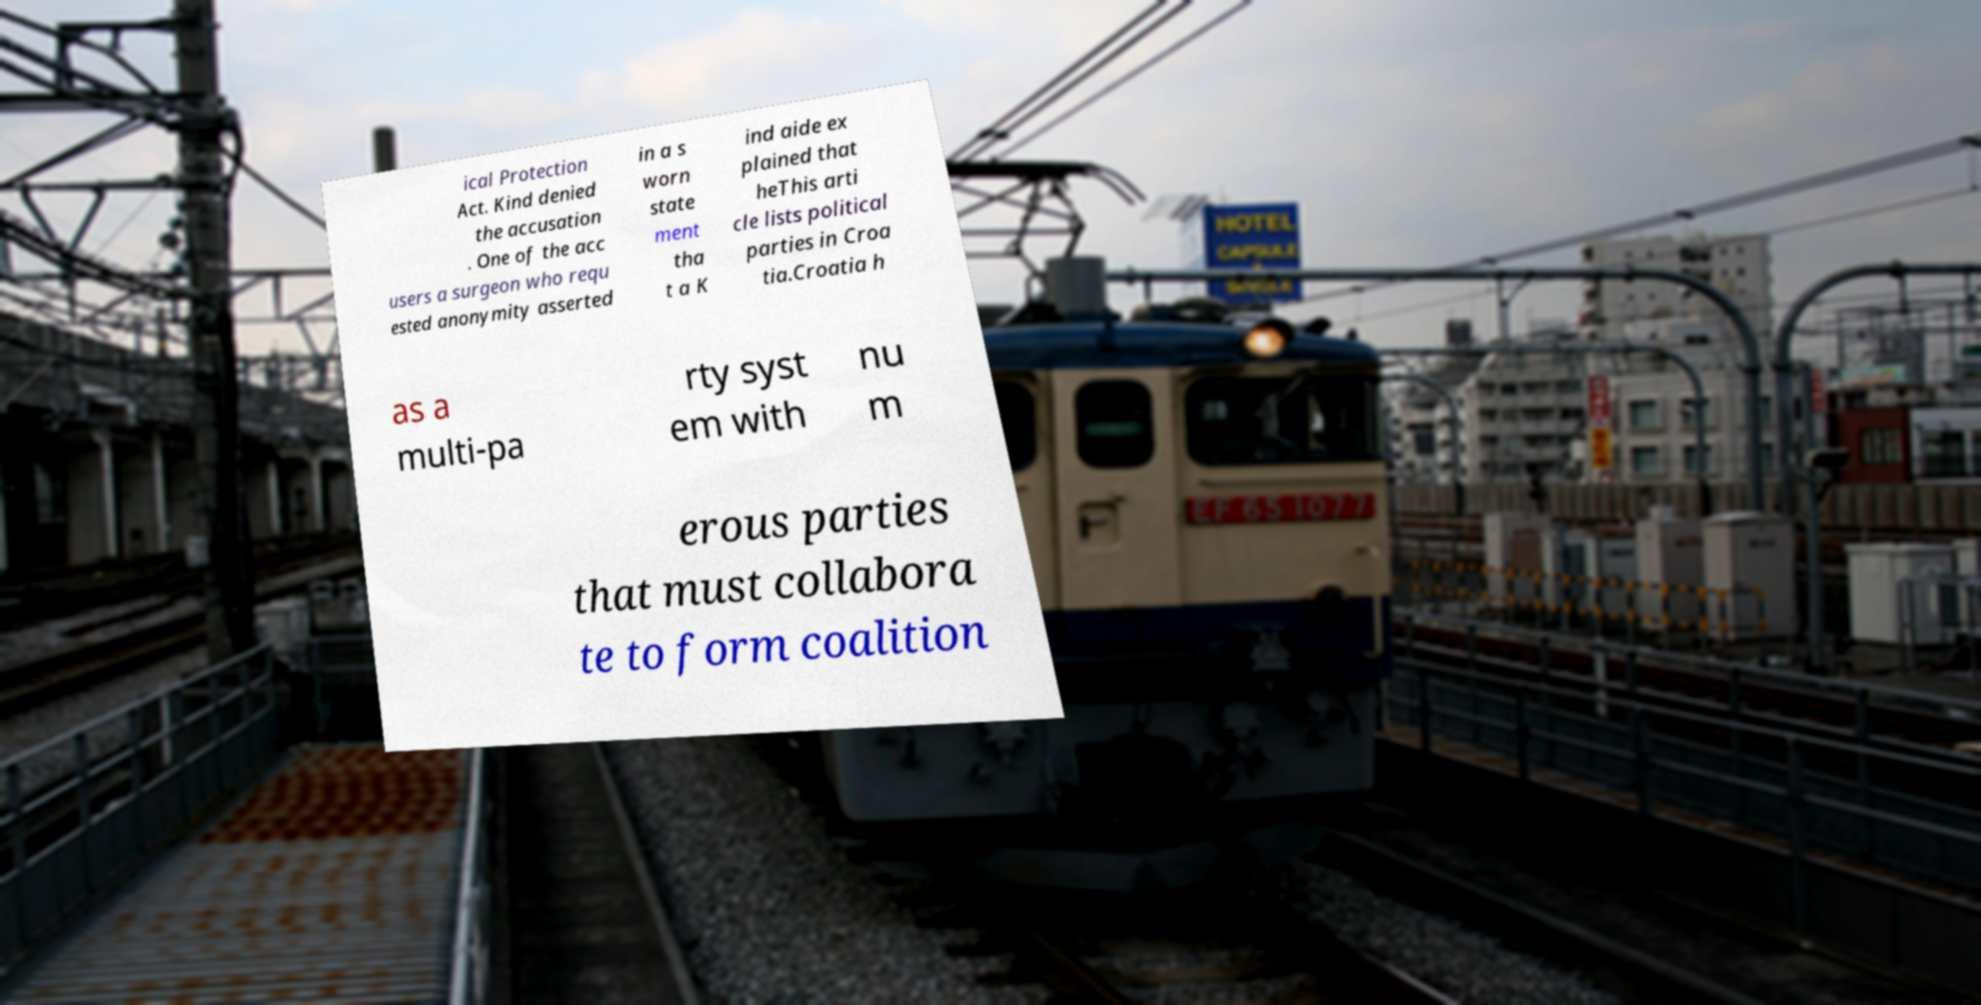Could you extract and type out the text from this image? ical Protection Act. Kind denied the accusation . One of the acc users a surgeon who requ ested anonymity asserted in a s worn state ment tha t a K ind aide ex plained that heThis arti cle lists political parties in Croa tia.Croatia h as a multi-pa rty syst em with nu m erous parties that must collabora te to form coalition 